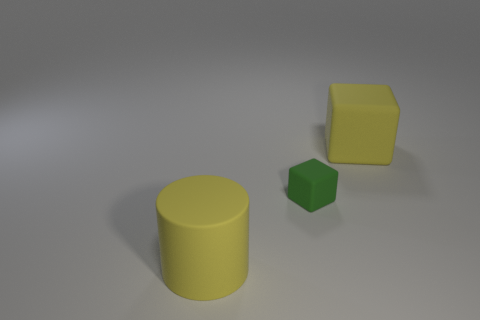There is a yellow thing that is the same size as the matte cylinder; what shape is it?
Ensure brevity in your answer.  Cube. Is there a big yellow rubber object of the same shape as the tiny thing?
Provide a short and direct response. Yes. What is the material of the cylinder?
Your answer should be compact. Rubber. Are there any large rubber blocks in front of the green matte block?
Offer a very short reply. No. How many tiny blocks are in front of the yellow matte object that is in front of the small green object?
Your response must be concise. 0. What material is the block that is the same size as the yellow rubber cylinder?
Make the answer very short. Rubber. How many other things are the same material as the big yellow cylinder?
Provide a succinct answer. 2. There is a small green rubber block; what number of blocks are right of it?
Offer a very short reply. 1. How many blocks are either rubber objects or small brown matte things?
Offer a terse response. 2. How big is the thing that is left of the yellow cube and on the right side of the yellow cylinder?
Your response must be concise. Small. 